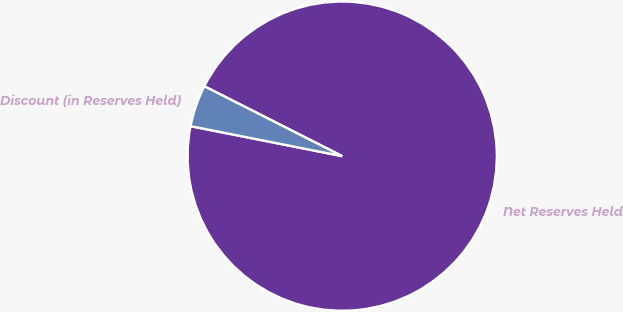<chart> <loc_0><loc_0><loc_500><loc_500><pie_chart><fcel>Net Reserves Held<fcel>Discount (in Reserves Held)<nl><fcel>95.64%<fcel>4.36%<nl></chart> 